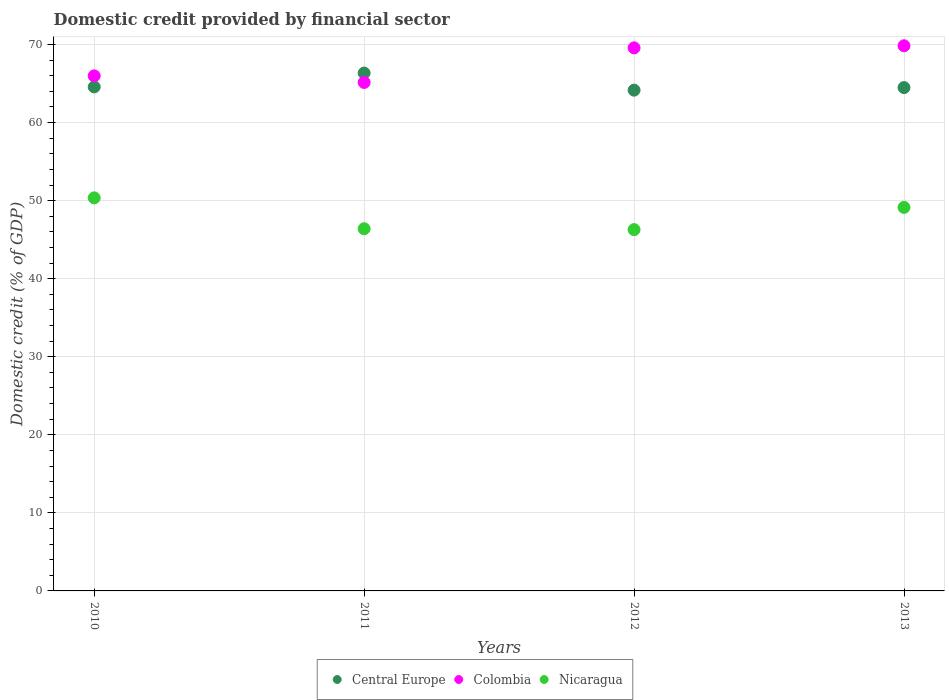How many different coloured dotlines are there?
Your response must be concise. 3. What is the domestic credit in Colombia in 2011?
Give a very brief answer. 65.14. Across all years, what is the maximum domestic credit in Colombia?
Keep it short and to the point. 69.84. Across all years, what is the minimum domestic credit in Colombia?
Provide a short and direct response. 65.14. What is the total domestic credit in Nicaragua in the graph?
Your answer should be compact. 192.18. What is the difference between the domestic credit in Nicaragua in 2011 and that in 2013?
Provide a short and direct response. -2.74. What is the difference between the domestic credit in Nicaragua in 2011 and the domestic credit in Colombia in 2012?
Provide a short and direct response. -23.18. What is the average domestic credit in Central Europe per year?
Your answer should be compact. 64.89. In the year 2011, what is the difference between the domestic credit in Central Europe and domestic credit in Nicaragua?
Provide a succinct answer. 19.95. In how many years, is the domestic credit in Nicaragua greater than 44 %?
Give a very brief answer. 4. What is the ratio of the domestic credit in Colombia in 2011 to that in 2013?
Offer a very short reply. 0.93. Is the difference between the domestic credit in Central Europe in 2010 and 2013 greater than the difference between the domestic credit in Nicaragua in 2010 and 2013?
Your answer should be compact. No. What is the difference between the highest and the second highest domestic credit in Colombia?
Provide a succinct answer. 0.27. What is the difference between the highest and the lowest domestic credit in Colombia?
Make the answer very short. 4.7. In how many years, is the domestic credit in Colombia greater than the average domestic credit in Colombia taken over all years?
Offer a very short reply. 2. How many dotlines are there?
Your answer should be compact. 3. How many years are there in the graph?
Your answer should be compact. 4. Does the graph contain grids?
Provide a succinct answer. Yes. What is the title of the graph?
Your answer should be very brief. Domestic credit provided by financial sector. Does "France" appear as one of the legend labels in the graph?
Give a very brief answer. No. What is the label or title of the Y-axis?
Ensure brevity in your answer.  Domestic credit (% of GDP). What is the Domestic credit (% of GDP) in Central Europe in 2010?
Offer a terse response. 64.57. What is the Domestic credit (% of GDP) of Colombia in 2010?
Offer a terse response. 65.99. What is the Domestic credit (% of GDP) of Nicaragua in 2010?
Make the answer very short. 50.36. What is the Domestic credit (% of GDP) in Central Europe in 2011?
Make the answer very short. 66.35. What is the Domestic credit (% of GDP) of Colombia in 2011?
Provide a succinct answer. 65.14. What is the Domestic credit (% of GDP) in Nicaragua in 2011?
Keep it short and to the point. 46.4. What is the Domestic credit (% of GDP) of Central Europe in 2012?
Offer a very short reply. 64.16. What is the Domestic credit (% of GDP) of Colombia in 2012?
Your response must be concise. 69.57. What is the Domestic credit (% of GDP) of Nicaragua in 2012?
Keep it short and to the point. 46.29. What is the Domestic credit (% of GDP) in Central Europe in 2013?
Make the answer very short. 64.49. What is the Domestic credit (% of GDP) in Colombia in 2013?
Make the answer very short. 69.84. What is the Domestic credit (% of GDP) of Nicaragua in 2013?
Make the answer very short. 49.13. Across all years, what is the maximum Domestic credit (% of GDP) of Central Europe?
Give a very brief answer. 66.35. Across all years, what is the maximum Domestic credit (% of GDP) in Colombia?
Give a very brief answer. 69.84. Across all years, what is the maximum Domestic credit (% of GDP) in Nicaragua?
Your answer should be compact. 50.36. Across all years, what is the minimum Domestic credit (% of GDP) in Central Europe?
Make the answer very short. 64.16. Across all years, what is the minimum Domestic credit (% of GDP) in Colombia?
Your answer should be very brief. 65.14. Across all years, what is the minimum Domestic credit (% of GDP) in Nicaragua?
Your answer should be very brief. 46.29. What is the total Domestic credit (% of GDP) in Central Europe in the graph?
Provide a short and direct response. 259.56. What is the total Domestic credit (% of GDP) in Colombia in the graph?
Provide a short and direct response. 270.55. What is the total Domestic credit (% of GDP) of Nicaragua in the graph?
Give a very brief answer. 192.18. What is the difference between the Domestic credit (% of GDP) of Central Europe in 2010 and that in 2011?
Ensure brevity in your answer.  -1.78. What is the difference between the Domestic credit (% of GDP) of Colombia in 2010 and that in 2011?
Offer a terse response. 0.84. What is the difference between the Domestic credit (% of GDP) of Nicaragua in 2010 and that in 2011?
Provide a short and direct response. 3.96. What is the difference between the Domestic credit (% of GDP) in Central Europe in 2010 and that in 2012?
Offer a terse response. 0.42. What is the difference between the Domestic credit (% of GDP) of Colombia in 2010 and that in 2012?
Your answer should be very brief. -3.59. What is the difference between the Domestic credit (% of GDP) of Nicaragua in 2010 and that in 2012?
Keep it short and to the point. 4.07. What is the difference between the Domestic credit (% of GDP) of Central Europe in 2010 and that in 2013?
Ensure brevity in your answer.  0.08. What is the difference between the Domestic credit (% of GDP) in Colombia in 2010 and that in 2013?
Ensure brevity in your answer.  -3.85. What is the difference between the Domestic credit (% of GDP) of Nicaragua in 2010 and that in 2013?
Offer a very short reply. 1.22. What is the difference between the Domestic credit (% of GDP) in Central Europe in 2011 and that in 2012?
Provide a short and direct response. 2.19. What is the difference between the Domestic credit (% of GDP) in Colombia in 2011 and that in 2012?
Offer a very short reply. -4.43. What is the difference between the Domestic credit (% of GDP) of Nicaragua in 2011 and that in 2012?
Ensure brevity in your answer.  0.11. What is the difference between the Domestic credit (% of GDP) of Central Europe in 2011 and that in 2013?
Make the answer very short. 1.86. What is the difference between the Domestic credit (% of GDP) in Colombia in 2011 and that in 2013?
Offer a very short reply. -4.7. What is the difference between the Domestic credit (% of GDP) of Nicaragua in 2011 and that in 2013?
Your answer should be very brief. -2.74. What is the difference between the Domestic credit (% of GDP) of Central Europe in 2012 and that in 2013?
Your answer should be compact. -0.33. What is the difference between the Domestic credit (% of GDP) of Colombia in 2012 and that in 2013?
Give a very brief answer. -0.27. What is the difference between the Domestic credit (% of GDP) in Nicaragua in 2012 and that in 2013?
Provide a succinct answer. -2.85. What is the difference between the Domestic credit (% of GDP) of Central Europe in 2010 and the Domestic credit (% of GDP) of Colombia in 2011?
Offer a terse response. -0.57. What is the difference between the Domestic credit (% of GDP) of Central Europe in 2010 and the Domestic credit (% of GDP) of Nicaragua in 2011?
Your answer should be compact. 18.17. What is the difference between the Domestic credit (% of GDP) of Colombia in 2010 and the Domestic credit (% of GDP) of Nicaragua in 2011?
Your response must be concise. 19.59. What is the difference between the Domestic credit (% of GDP) in Central Europe in 2010 and the Domestic credit (% of GDP) in Colombia in 2012?
Keep it short and to the point. -5. What is the difference between the Domestic credit (% of GDP) in Central Europe in 2010 and the Domestic credit (% of GDP) in Nicaragua in 2012?
Provide a succinct answer. 18.28. What is the difference between the Domestic credit (% of GDP) in Colombia in 2010 and the Domestic credit (% of GDP) in Nicaragua in 2012?
Provide a short and direct response. 19.7. What is the difference between the Domestic credit (% of GDP) in Central Europe in 2010 and the Domestic credit (% of GDP) in Colombia in 2013?
Provide a short and direct response. -5.27. What is the difference between the Domestic credit (% of GDP) in Central Europe in 2010 and the Domestic credit (% of GDP) in Nicaragua in 2013?
Give a very brief answer. 15.44. What is the difference between the Domestic credit (% of GDP) in Colombia in 2010 and the Domestic credit (% of GDP) in Nicaragua in 2013?
Provide a short and direct response. 16.85. What is the difference between the Domestic credit (% of GDP) of Central Europe in 2011 and the Domestic credit (% of GDP) of Colombia in 2012?
Your answer should be very brief. -3.23. What is the difference between the Domestic credit (% of GDP) in Central Europe in 2011 and the Domestic credit (% of GDP) in Nicaragua in 2012?
Provide a succinct answer. 20.06. What is the difference between the Domestic credit (% of GDP) of Colombia in 2011 and the Domestic credit (% of GDP) of Nicaragua in 2012?
Ensure brevity in your answer.  18.86. What is the difference between the Domestic credit (% of GDP) in Central Europe in 2011 and the Domestic credit (% of GDP) in Colombia in 2013?
Your answer should be compact. -3.49. What is the difference between the Domestic credit (% of GDP) of Central Europe in 2011 and the Domestic credit (% of GDP) of Nicaragua in 2013?
Offer a terse response. 17.21. What is the difference between the Domestic credit (% of GDP) of Colombia in 2011 and the Domestic credit (% of GDP) of Nicaragua in 2013?
Keep it short and to the point. 16.01. What is the difference between the Domestic credit (% of GDP) of Central Europe in 2012 and the Domestic credit (% of GDP) of Colombia in 2013?
Ensure brevity in your answer.  -5.69. What is the difference between the Domestic credit (% of GDP) in Central Europe in 2012 and the Domestic credit (% of GDP) in Nicaragua in 2013?
Ensure brevity in your answer.  15.02. What is the difference between the Domestic credit (% of GDP) in Colombia in 2012 and the Domestic credit (% of GDP) in Nicaragua in 2013?
Your answer should be compact. 20.44. What is the average Domestic credit (% of GDP) of Central Europe per year?
Provide a succinct answer. 64.89. What is the average Domestic credit (% of GDP) of Colombia per year?
Make the answer very short. 67.64. What is the average Domestic credit (% of GDP) of Nicaragua per year?
Ensure brevity in your answer.  48.05. In the year 2010, what is the difference between the Domestic credit (% of GDP) in Central Europe and Domestic credit (% of GDP) in Colombia?
Your answer should be very brief. -1.42. In the year 2010, what is the difference between the Domestic credit (% of GDP) of Central Europe and Domestic credit (% of GDP) of Nicaragua?
Provide a short and direct response. 14.21. In the year 2010, what is the difference between the Domestic credit (% of GDP) in Colombia and Domestic credit (% of GDP) in Nicaragua?
Ensure brevity in your answer.  15.63. In the year 2011, what is the difference between the Domestic credit (% of GDP) in Central Europe and Domestic credit (% of GDP) in Colombia?
Provide a short and direct response. 1.2. In the year 2011, what is the difference between the Domestic credit (% of GDP) of Central Europe and Domestic credit (% of GDP) of Nicaragua?
Offer a very short reply. 19.95. In the year 2011, what is the difference between the Domestic credit (% of GDP) in Colombia and Domestic credit (% of GDP) in Nicaragua?
Make the answer very short. 18.74. In the year 2012, what is the difference between the Domestic credit (% of GDP) in Central Europe and Domestic credit (% of GDP) in Colombia?
Your response must be concise. -5.42. In the year 2012, what is the difference between the Domestic credit (% of GDP) in Central Europe and Domestic credit (% of GDP) in Nicaragua?
Ensure brevity in your answer.  17.87. In the year 2012, what is the difference between the Domestic credit (% of GDP) of Colombia and Domestic credit (% of GDP) of Nicaragua?
Offer a very short reply. 23.29. In the year 2013, what is the difference between the Domestic credit (% of GDP) of Central Europe and Domestic credit (% of GDP) of Colombia?
Provide a succinct answer. -5.36. In the year 2013, what is the difference between the Domestic credit (% of GDP) in Central Europe and Domestic credit (% of GDP) in Nicaragua?
Ensure brevity in your answer.  15.35. In the year 2013, what is the difference between the Domestic credit (% of GDP) of Colombia and Domestic credit (% of GDP) of Nicaragua?
Your answer should be very brief. 20.71. What is the ratio of the Domestic credit (% of GDP) of Central Europe in 2010 to that in 2011?
Ensure brevity in your answer.  0.97. What is the ratio of the Domestic credit (% of GDP) in Nicaragua in 2010 to that in 2011?
Provide a succinct answer. 1.09. What is the ratio of the Domestic credit (% of GDP) in Central Europe in 2010 to that in 2012?
Provide a succinct answer. 1.01. What is the ratio of the Domestic credit (% of GDP) in Colombia in 2010 to that in 2012?
Your answer should be very brief. 0.95. What is the ratio of the Domestic credit (% of GDP) in Nicaragua in 2010 to that in 2012?
Your answer should be very brief. 1.09. What is the ratio of the Domestic credit (% of GDP) in Central Europe in 2010 to that in 2013?
Provide a succinct answer. 1. What is the ratio of the Domestic credit (% of GDP) in Colombia in 2010 to that in 2013?
Provide a succinct answer. 0.94. What is the ratio of the Domestic credit (% of GDP) in Nicaragua in 2010 to that in 2013?
Make the answer very short. 1.02. What is the ratio of the Domestic credit (% of GDP) in Central Europe in 2011 to that in 2012?
Make the answer very short. 1.03. What is the ratio of the Domestic credit (% of GDP) of Colombia in 2011 to that in 2012?
Keep it short and to the point. 0.94. What is the ratio of the Domestic credit (% of GDP) of Nicaragua in 2011 to that in 2012?
Give a very brief answer. 1. What is the ratio of the Domestic credit (% of GDP) in Central Europe in 2011 to that in 2013?
Your answer should be very brief. 1.03. What is the ratio of the Domestic credit (% of GDP) in Colombia in 2011 to that in 2013?
Provide a succinct answer. 0.93. What is the ratio of the Domestic credit (% of GDP) in Nicaragua in 2011 to that in 2013?
Provide a succinct answer. 0.94. What is the ratio of the Domestic credit (% of GDP) of Nicaragua in 2012 to that in 2013?
Provide a succinct answer. 0.94. What is the difference between the highest and the second highest Domestic credit (% of GDP) of Central Europe?
Provide a succinct answer. 1.78. What is the difference between the highest and the second highest Domestic credit (% of GDP) in Colombia?
Your response must be concise. 0.27. What is the difference between the highest and the second highest Domestic credit (% of GDP) in Nicaragua?
Make the answer very short. 1.22. What is the difference between the highest and the lowest Domestic credit (% of GDP) in Central Europe?
Provide a short and direct response. 2.19. What is the difference between the highest and the lowest Domestic credit (% of GDP) in Colombia?
Provide a short and direct response. 4.7. What is the difference between the highest and the lowest Domestic credit (% of GDP) of Nicaragua?
Offer a very short reply. 4.07. 